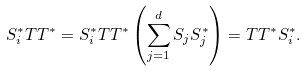<formula> <loc_0><loc_0><loc_500><loc_500>S _ { i } ^ { * } T T ^ { * } = S _ { i } ^ { * } T T ^ { * } \left ( \sum _ { j = 1 } ^ { d } S _ { j } S _ { j } ^ { * } \right ) = T T ^ { * } S _ { i } ^ { * } .</formula> 